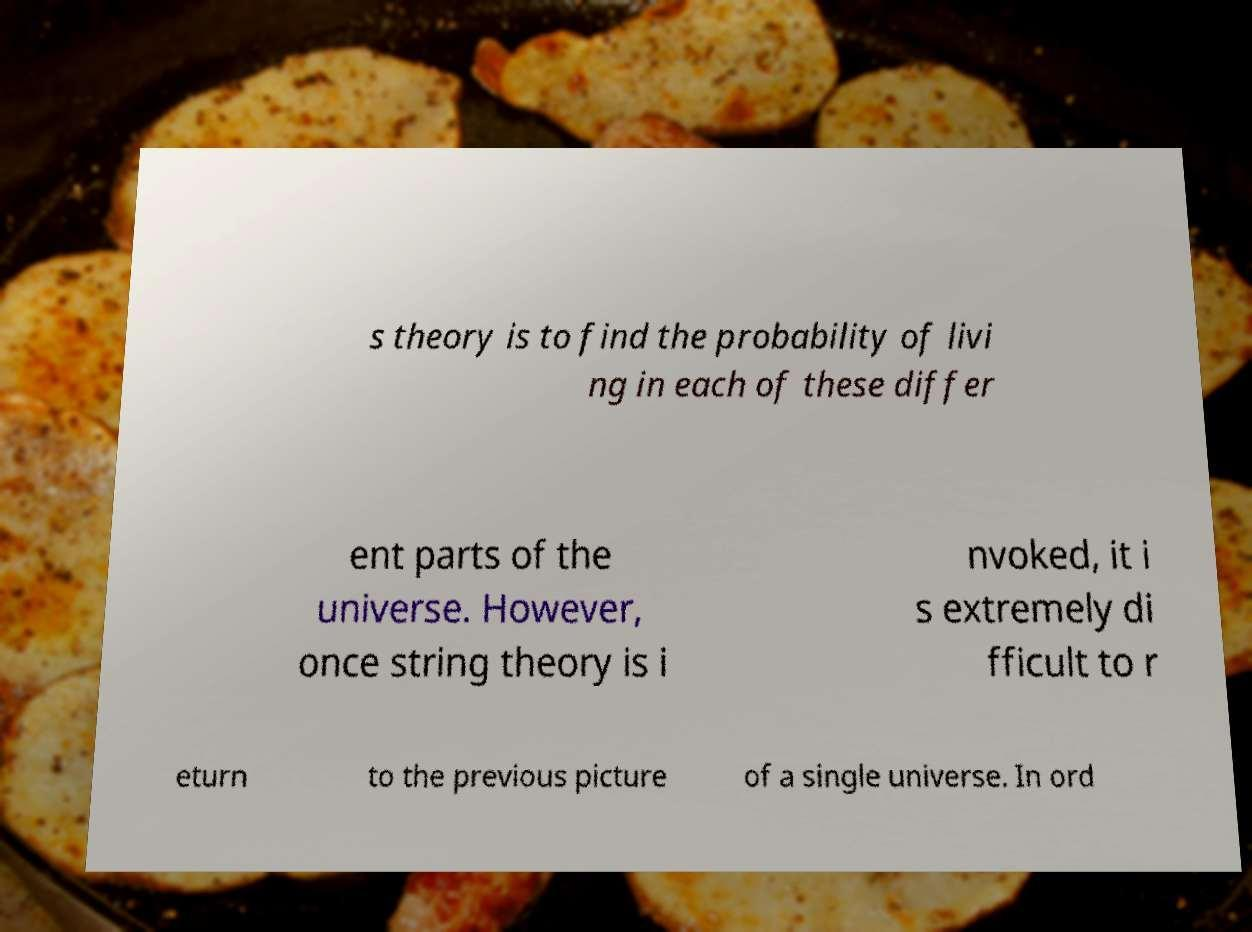I need the written content from this picture converted into text. Can you do that? s theory is to find the probability of livi ng in each of these differ ent parts of the universe. However, once string theory is i nvoked, it i s extremely di fficult to r eturn to the previous picture of a single universe. In ord 